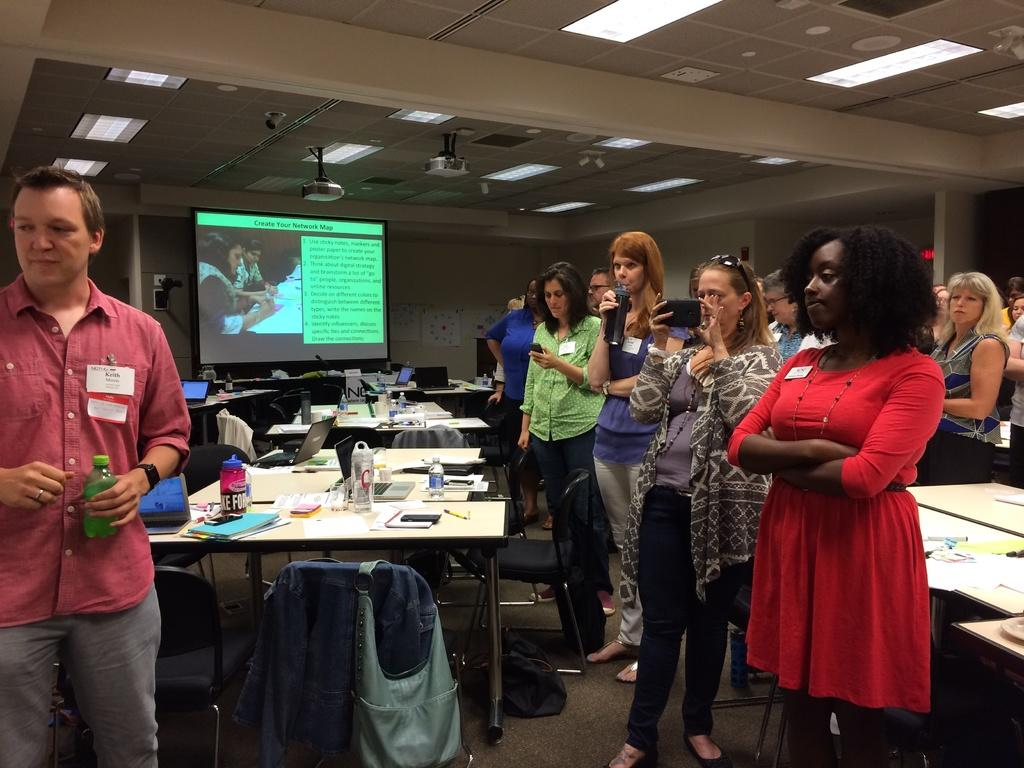Who is the main subject in the image? There is a man in the image. What is the man doing in the image? The man is standing in the image. What is the man holding in the image? The man is holding a bottle in the image. Are there any other people in the image? Yes, there are people in the image. What are the people doing in the image? The people are watching the man in the image. How many snakes are wrapped around the man's legs in the image? There are no snakes present in the image; the man is holding a bottle and standing. What type of pie is the man holding in the image? There is no pie present in the image; the man is holding a bottle. 